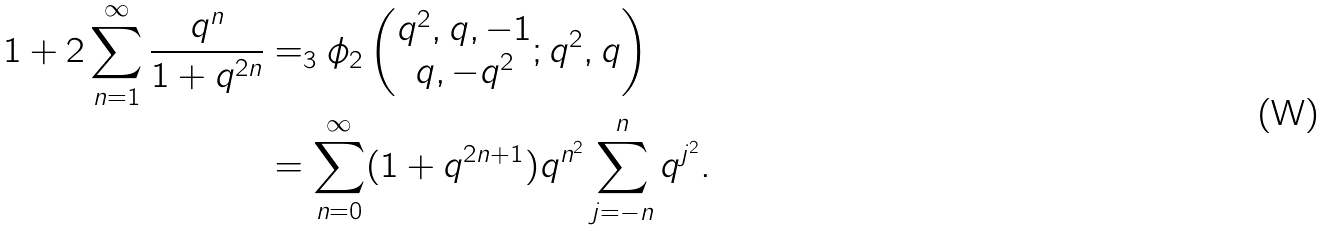<formula> <loc_0><loc_0><loc_500><loc_500>1 + 2 \sum _ { n = 1 } ^ { \infty } \frac { q ^ { n } } { 1 + q ^ { 2 n } } & = _ { 3 } \phi _ { 2 } \left ( \begin{matrix} q ^ { 2 } , q , - 1 \\ q , - q ^ { 2 } \end{matrix} ; q ^ { 2 } , q \right ) \\ & = \sum _ { n = 0 } ^ { \infty } ( 1 + q ^ { 2 n + 1 } ) q ^ { n ^ { 2 } } \sum _ { j = - n } ^ { n } q ^ { j ^ { 2 } } .</formula> 